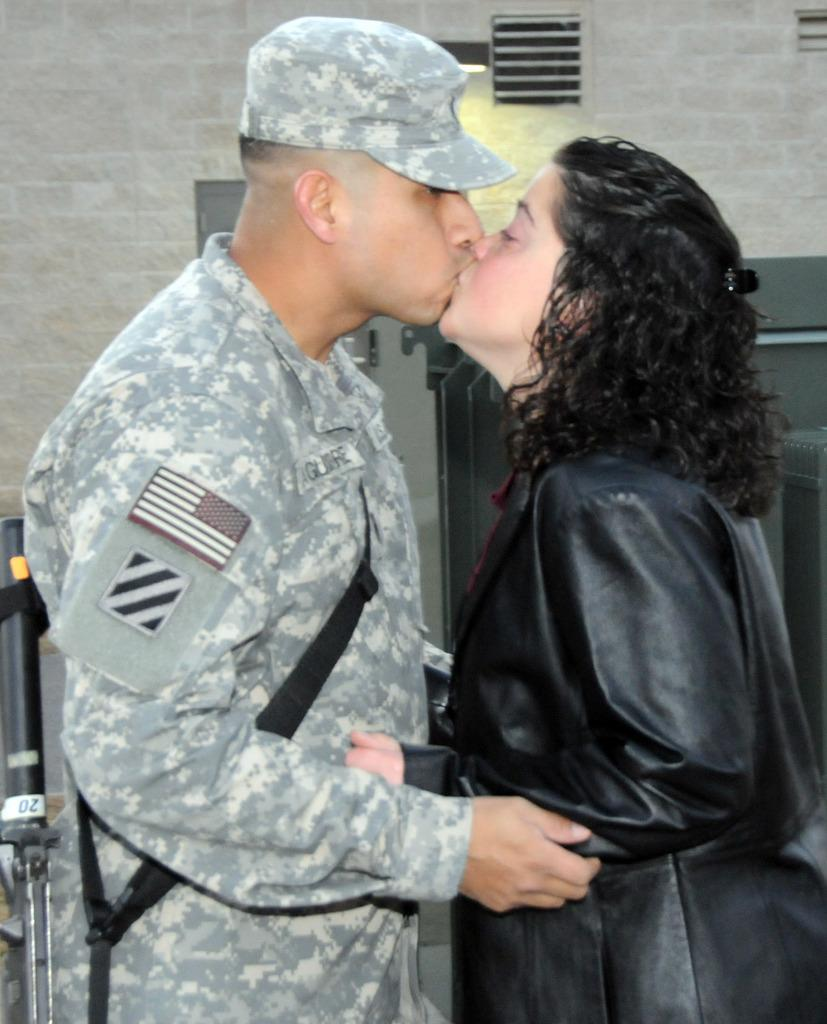How many people are in the image? There are two persons in the image. What are the two persons doing? The two persons are kissing each other. What can be seen on the wall in the image? The wall has a door and a ventilator. Can you describe the object in the bottom left side of the image? Unfortunately, the provided facts do not give enough information to describe the object in the bottom left side of the image. What causes the sneeze in the image? There is no sneeze present in the image. What is the topic of the argument between the two persons in the image? There is no argument present in the image; the two persons are kissing each other. 